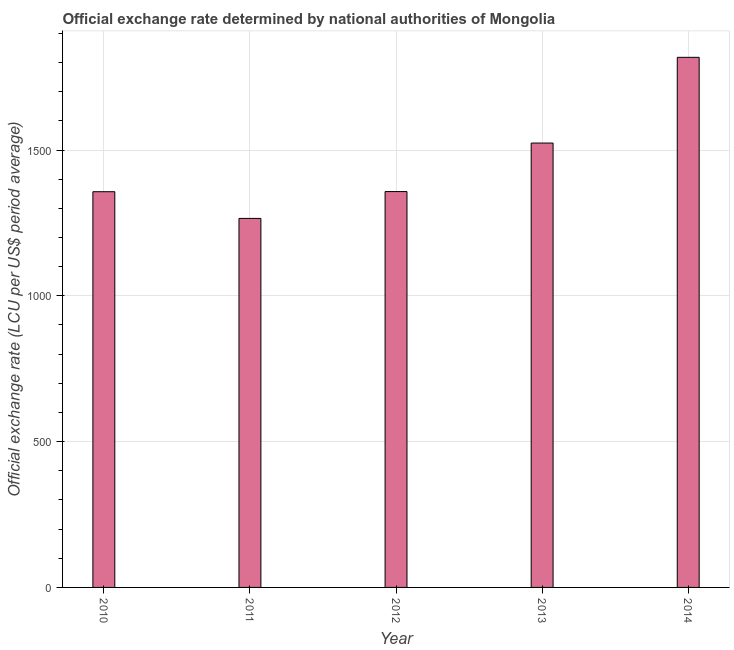Does the graph contain grids?
Provide a short and direct response. Yes. What is the title of the graph?
Ensure brevity in your answer.  Official exchange rate determined by national authorities of Mongolia. What is the label or title of the X-axis?
Offer a terse response. Year. What is the label or title of the Y-axis?
Your answer should be compact. Official exchange rate (LCU per US$ period average). What is the official exchange rate in 2014?
Keep it short and to the point. 1817.94. Across all years, what is the maximum official exchange rate?
Make the answer very short. 1817.94. Across all years, what is the minimum official exchange rate?
Keep it short and to the point. 1265.52. In which year was the official exchange rate maximum?
Your answer should be very brief. 2014. What is the sum of the official exchange rate?
Provide a short and direct response. 7322.03. What is the difference between the official exchange rate in 2013 and 2014?
Your answer should be compact. -294.01. What is the average official exchange rate per year?
Give a very brief answer. 1464.4. What is the median official exchange rate?
Your answer should be very brief. 1357.58. In how many years, is the official exchange rate greater than 100 ?
Keep it short and to the point. 5. What is the ratio of the official exchange rate in 2012 to that in 2013?
Your answer should be compact. 0.89. Is the official exchange rate in 2011 less than that in 2014?
Your answer should be very brief. Yes. Is the difference between the official exchange rate in 2011 and 2013 greater than the difference between any two years?
Your response must be concise. No. What is the difference between the highest and the second highest official exchange rate?
Offer a very short reply. 294.01. Is the sum of the official exchange rate in 2010 and 2013 greater than the maximum official exchange rate across all years?
Provide a succinct answer. Yes. What is the difference between the highest and the lowest official exchange rate?
Offer a terse response. 552.42. In how many years, is the official exchange rate greater than the average official exchange rate taken over all years?
Keep it short and to the point. 2. Are all the bars in the graph horizontal?
Make the answer very short. No. How many years are there in the graph?
Provide a succinct answer. 5. What is the Official exchange rate (LCU per US$ period average) of 2010?
Your response must be concise. 1357.06. What is the Official exchange rate (LCU per US$ period average) of 2011?
Keep it short and to the point. 1265.52. What is the Official exchange rate (LCU per US$ period average) in 2012?
Ensure brevity in your answer.  1357.58. What is the Official exchange rate (LCU per US$ period average) in 2013?
Your answer should be very brief. 1523.93. What is the Official exchange rate (LCU per US$ period average) of 2014?
Your answer should be compact. 1817.94. What is the difference between the Official exchange rate (LCU per US$ period average) in 2010 and 2011?
Your answer should be very brief. 91.55. What is the difference between the Official exchange rate (LCU per US$ period average) in 2010 and 2012?
Provide a short and direct response. -0.52. What is the difference between the Official exchange rate (LCU per US$ period average) in 2010 and 2013?
Your answer should be compact. -166.86. What is the difference between the Official exchange rate (LCU per US$ period average) in 2010 and 2014?
Keep it short and to the point. -460.87. What is the difference between the Official exchange rate (LCU per US$ period average) in 2011 and 2012?
Give a very brief answer. -92.06. What is the difference between the Official exchange rate (LCU per US$ period average) in 2011 and 2013?
Your response must be concise. -258.41. What is the difference between the Official exchange rate (LCU per US$ period average) in 2011 and 2014?
Provide a short and direct response. -552.42. What is the difference between the Official exchange rate (LCU per US$ period average) in 2012 and 2013?
Your answer should be very brief. -166.35. What is the difference between the Official exchange rate (LCU per US$ period average) in 2012 and 2014?
Ensure brevity in your answer.  -460.36. What is the difference between the Official exchange rate (LCU per US$ period average) in 2013 and 2014?
Your response must be concise. -294.01. What is the ratio of the Official exchange rate (LCU per US$ period average) in 2010 to that in 2011?
Ensure brevity in your answer.  1.07. What is the ratio of the Official exchange rate (LCU per US$ period average) in 2010 to that in 2012?
Give a very brief answer. 1. What is the ratio of the Official exchange rate (LCU per US$ period average) in 2010 to that in 2013?
Keep it short and to the point. 0.89. What is the ratio of the Official exchange rate (LCU per US$ period average) in 2010 to that in 2014?
Provide a short and direct response. 0.75. What is the ratio of the Official exchange rate (LCU per US$ period average) in 2011 to that in 2012?
Offer a terse response. 0.93. What is the ratio of the Official exchange rate (LCU per US$ period average) in 2011 to that in 2013?
Make the answer very short. 0.83. What is the ratio of the Official exchange rate (LCU per US$ period average) in 2011 to that in 2014?
Provide a succinct answer. 0.7. What is the ratio of the Official exchange rate (LCU per US$ period average) in 2012 to that in 2013?
Provide a short and direct response. 0.89. What is the ratio of the Official exchange rate (LCU per US$ period average) in 2012 to that in 2014?
Your response must be concise. 0.75. What is the ratio of the Official exchange rate (LCU per US$ period average) in 2013 to that in 2014?
Offer a terse response. 0.84. 